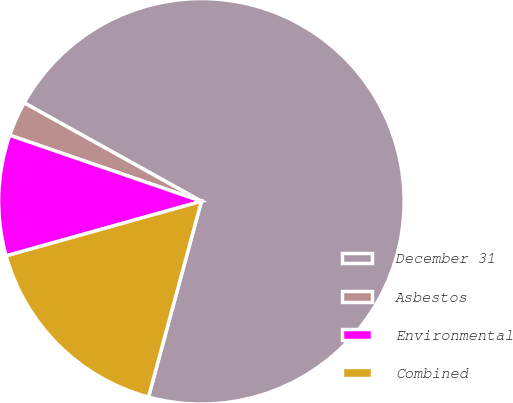<chart> <loc_0><loc_0><loc_500><loc_500><pie_chart><fcel>December 31<fcel>Asbestos<fcel>Environmental<fcel>Combined<nl><fcel>71.13%<fcel>2.79%<fcel>9.62%<fcel>16.46%<nl></chart> 